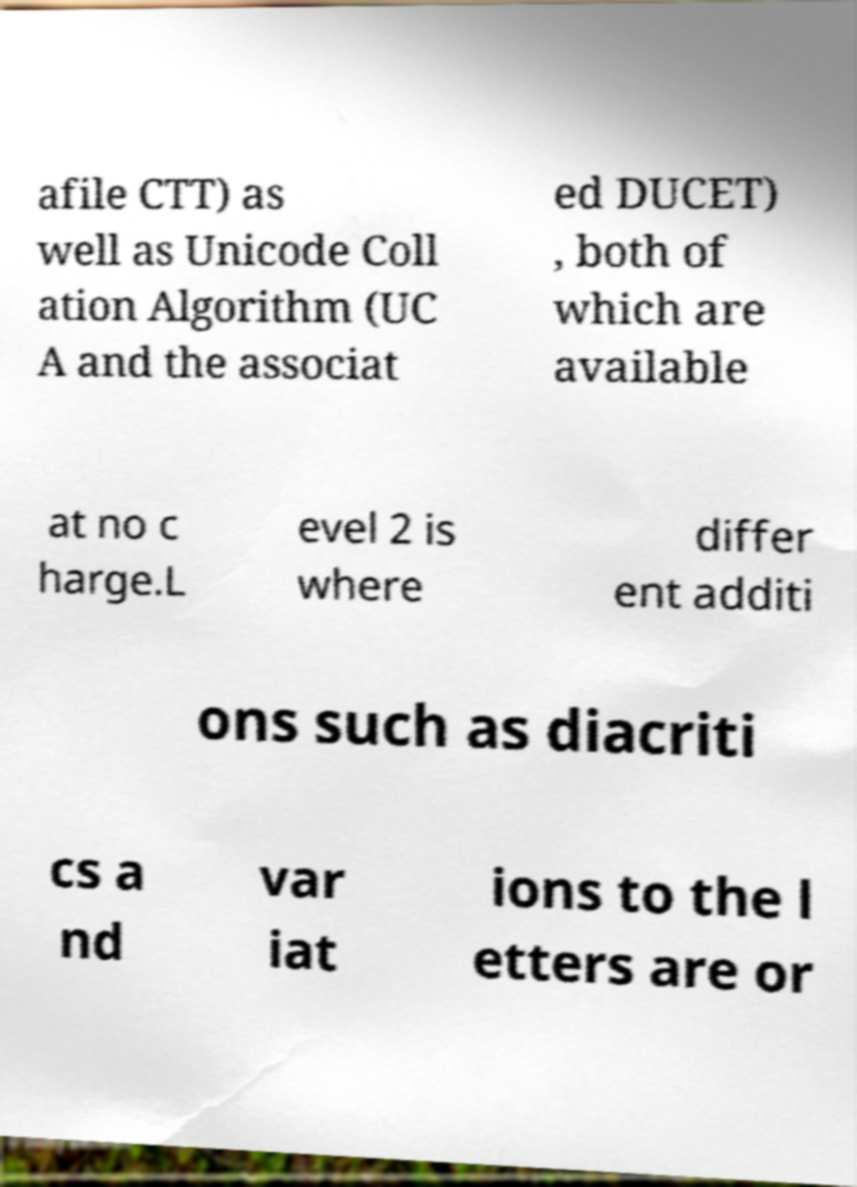There's text embedded in this image that I need extracted. Can you transcribe it verbatim? afile CTT) as well as Unicode Coll ation Algorithm (UC A and the associat ed DUCET) , both of which are available at no c harge.L evel 2 is where differ ent additi ons such as diacriti cs a nd var iat ions to the l etters are or 